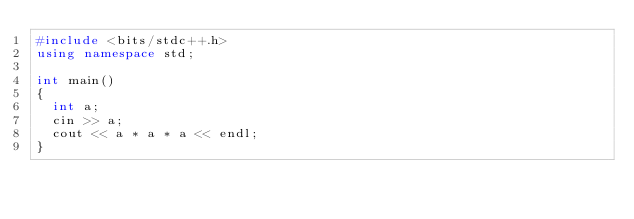Convert code to text. <code><loc_0><loc_0><loc_500><loc_500><_C++_>#include <bits/stdc++.h>
using namespace std;

int main()
{
  int a;
  cin >> a;
  cout << a * a * a << endl;
}</code> 